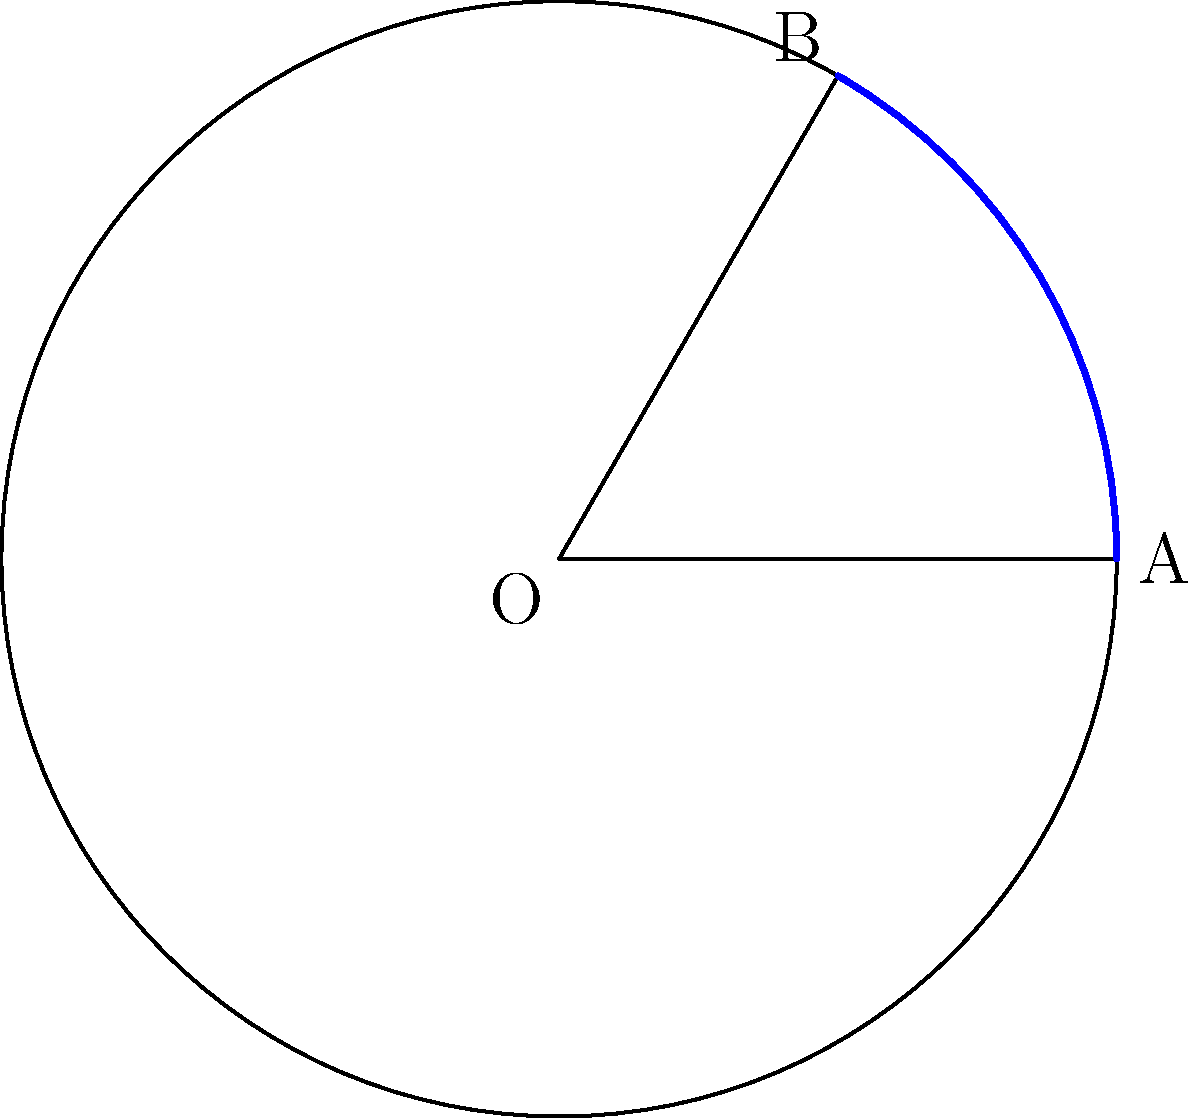A client wants a mandala tattoo with a curved arc as part of the design. The arc is part of a circle with radius 6 cm, and it spans an angle of 60°. What is the length of the curved arc in centimeters? To find the length of the curved arc, we need to use the formula for arc length:

$$ \text{Arc Length} = r \theta $$

Where:
- $r$ is the radius of the circle
- $\theta$ is the central angle in radians

Step 1: Convert the angle from degrees to radians
$60^\circ = \frac{60 \pi}{180} = \frac{\pi}{3}$ radians

Step 2: Apply the arc length formula
$$ \text{Arc Length} = r \theta = 6 \cdot \frac{\pi}{3} = 2\pi \text{ cm} $$

Therefore, the length of the curved arc in the mandala tattoo design is $2\pi$ cm.
Answer: $2\pi$ cm 